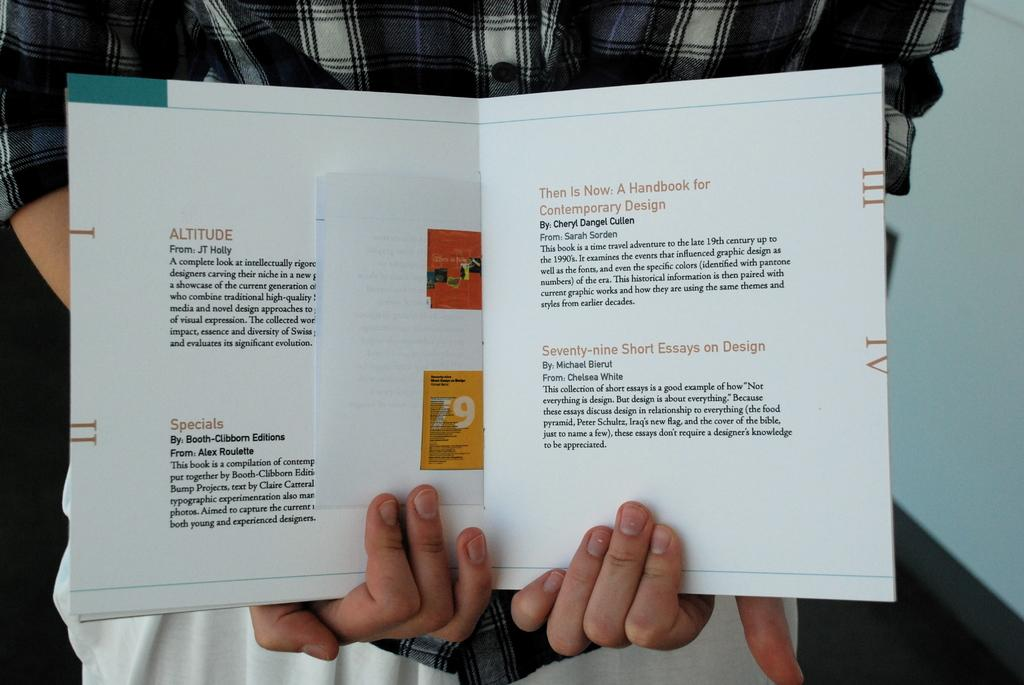Provide a one-sentence caption for the provided image. Person showing off a page that starts off by talking about Altitude. 